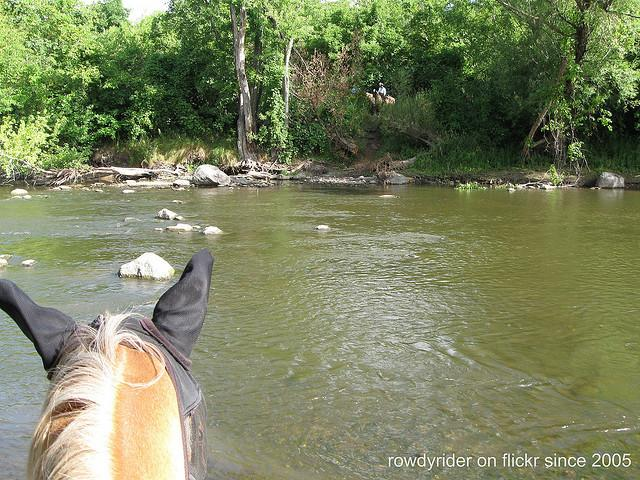What is the maximum speed of this type of animal in miles per hour? 55 